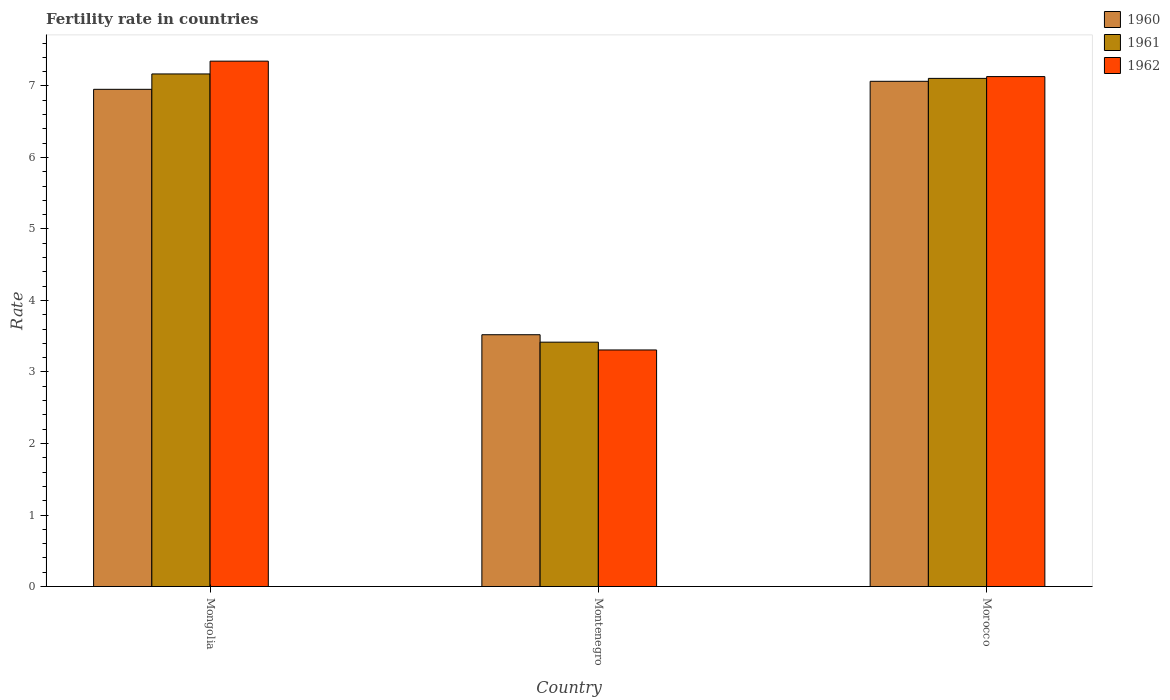How many different coloured bars are there?
Your response must be concise. 3. How many groups of bars are there?
Make the answer very short. 3. Are the number of bars per tick equal to the number of legend labels?
Give a very brief answer. Yes. How many bars are there on the 1st tick from the left?
Provide a short and direct response. 3. How many bars are there on the 2nd tick from the right?
Provide a succinct answer. 3. What is the label of the 1st group of bars from the left?
Give a very brief answer. Mongolia. In how many cases, is the number of bars for a given country not equal to the number of legend labels?
Provide a succinct answer. 0. What is the fertility rate in 1962 in Montenegro?
Offer a very short reply. 3.31. Across all countries, what is the maximum fertility rate in 1960?
Provide a succinct answer. 7.07. Across all countries, what is the minimum fertility rate in 1962?
Your answer should be very brief. 3.31. In which country was the fertility rate in 1960 maximum?
Give a very brief answer. Morocco. In which country was the fertility rate in 1962 minimum?
Your response must be concise. Montenegro. What is the total fertility rate in 1962 in the graph?
Keep it short and to the point. 17.79. What is the difference between the fertility rate in 1962 in Mongolia and that in Montenegro?
Your answer should be very brief. 4.04. What is the difference between the fertility rate in 1962 in Morocco and the fertility rate in 1960 in Mongolia?
Give a very brief answer. 0.18. What is the average fertility rate in 1961 per country?
Your answer should be compact. 5.9. What is the difference between the fertility rate of/in 1960 and fertility rate of/in 1962 in Montenegro?
Provide a short and direct response. 0.21. In how many countries, is the fertility rate in 1962 greater than 1?
Provide a short and direct response. 3. What is the ratio of the fertility rate in 1961 in Mongolia to that in Montenegro?
Your answer should be compact. 2.1. Is the fertility rate in 1960 in Mongolia less than that in Montenegro?
Give a very brief answer. No. What is the difference between the highest and the second highest fertility rate in 1960?
Offer a very short reply. -3.43. What is the difference between the highest and the lowest fertility rate in 1960?
Offer a very short reply. 3.54. In how many countries, is the fertility rate in 1962 greater than the average fertility rate in 1962 taken over all countries?
Offer a terse response. 2. Is the sum of the fertility rate in 1961 in Montenegro and Morocco greater than the maximum fertility rate in 1962 across all countries?
Offer a very short reply. Yes. How many bars are there?
Offer a terse response. 9. Are the values on the major ticks of Y-axis written in scientific E-notation?
Keep it short and to the point. No. Where does the legend appear in the graph?
Your answer should be compact. Top right. How are the legend labels stacked?
Your answer should be compact. Vertical. What is the title of the graph?
Give a very brief answer. Fertility rate in countries. What is the label or title of the Y-axis?
Your answer should be compact. Rate. What is the Rate of 1960 in Mongolia?
Ensure brevity in your answer.  6.95. What is the Rate of 1961 in Mongolia?
Provide a succinct answer. 7.17. What is the Rate of 1962 in Mongolia?
Keep it short and to the point. 7.35. What is the Rate of 1960 in Montenegro?
Offer a terse response. 3.52. What is the Rate in 1961 in Montenegro?
Your answer should be compact. 3.42. What is the Rate in 1962 in Montenegro?
Ensure brevity in your answer.  3.31. What is the Rate in 1960 in Morocco?
Your answer should be compact. 7.07. What is the Rate in 1961 in Morocco?
Your answer should be very brief. 7.11. What is the Rate in 1962 in Morocco?
Provide a short and direct response. 7.13. Across all countries, what is the maximum Rate in 1960?
Your answer should be very brief. 7.07. Across all countries, what is the maximum Rate of 1961?
Give a very brief answer. 7.17. Across all countries, what is the maximum Rate of 1962?
Offer a terse response. 7.35. Across all countries, what is the minimum Rate in 1960?
Ensure brevity in your answer.  3.52. Across all countries, what is the minimum Rate of 1961?
Give a very brief answer. 3.42. Across all countries, what is the minimum Rate in 1962?
Offer a terse response. 3.31. What is the total Rate of 1960 in the graph?
Your answer should be compact. 17.54. What is the total Rate of 1961 in the graph?
Your answer should be compact. 17.69. What is the total Rate of 1962 in the graph?
Ensure brevity in your answer.  17.79. What is the difference between the Rate of 1960 in Mongolia and that in Montenegro?
Provide a short and direct response. 3.43. What is the difference between the Rate of 1961 in Mongolia and that in Montenegro?
Provide a succinct answer. 3.75. What is the difference between the Rate in 1962 in Mongolia and that in Montenegro?
Ensure brevity in your answer.  4.04. What is the difference between the Rate in 1960 in Mongolia and that in Morocco?
Give a very brief answer. -0.11. What is the difference between the Rate of 1961 in Mongolia and that in Morocco?
Make the answer very short. 0.06. What is the difference between the Rate in 1962 in Mongolia and that in Morocco?
Make the answer very short. 0.22. What is the difference between the Rate in 1960 in Montenegro and that in Morocco?
Provide a short and direct response. -3.54. What is the difference between the Rate in 1961 in Montenegro and that in Morocco?
Your response must be concise. -3.69. What is the difference between the Rate of 1962 in Montenegro and that in Morocco?
Provide a short and direct response. -3.82. What is the difference between the Rate in 1960 in Mongolia and the Rate in 1961 in Montenegro?
Offer a terse response. 3.54. What is the difference between the Rate in 1960 in Mongolia and the Rate in 1962 in Montenegro?
Your answer should be very brief. 3.65. What is the difference between the Rate in 1961 in Mongolia and the Rate in 1962 in Montenegro?
Your response must be concise. 3.86. What is the difference between the Rate of 1960 in Mongolia and the Rate of 1961 in Morocco?
Provide a short and direct response. -0.15. What is the difference between the Rate of 1960 in Mongolia and the Rate of 1962 in Morocco?
Provide a succinct answer. -0.18. What is the difference between the Rate of 1961 in Mongolia and the Rate of 1962 in Morocco?
Your answer should be compact. 0.04. What is the difference between the Rate in 1960 in Montenegro and the Rate in 1961 in Morocco?
Your answer should be compact. -3.58. What is the difference between the Rate of 1960 in Montenegro and the Rate of 1962 in Morocco?
Your response must be concise. -3.61. What is the difference between the Rate in 1961 in Montenegro and the Rate in 1962 in Morocco?
Provide a short and direct response. -3.71. What is the average Rate of 1960 per country?
Your answer should be very brief. 5.85. What is the average Rate of 1961 per country?
Provide a short and direct response. 5.9. What is the average Rate in 1962 per country?
Make the answer very short. 5.93. What is the difference between the Rate of 1960 and Rate of 1961 in Mongolia?
Your answer should be very brief. -0.21. What is the difference between the Rate in 1960 and Rate in 1962 in Mongolia?
Provide a succinct answer. -0.39. What is the difference between the Rate of 1961 and Rate of 1962 in Mongolia?
Provide a succinct answer. -0.18. What is the difference between the Rate of 1960 and Rate of 1961 in Montenegro?
Offer a terse response. 0.1. What is the difference between the Rate in 1960 and Rate in 1962 in Montenegro?
Offer a very short reply. 0.21. What is the difference between the Rate of 1961 and Rate of 1962 in Montenegro?
Give a very brief answer. 0.11. What is the difference between the Rate in 1960 and Rate in 1961 in Morocco?
Provide a succinct answer. -0.04. What is the difference between the Rate in 1960 and Rate in 1962 in Morocco?
Ensure brevity in your answer.  -0.07. What is the difference between the Rate in 1961 and Rate in 1962 in Morocco?
Your answer should be compact. -0.03. What is the ratio of the Rate in 1960 in Mongolia to that in Montenegro?
Give a very brief answer. 1.97. What is the ratio of the Rate in 1961 in Mongolia to that in Montenegro?
Keep it short and to the point. 2.1. What is the ratio of the Rate of 1962 in Mongolia to that in Montenegro?
Give a very brief answer. 2.22. What is the ratio of the Rate in 1960 in Mongolia to that in Morocco?
Ensure brevity in your answer.  0.98. What is the ratio of the Rate in 1961 in Mongolia to that in Morocco?
Keep it short and to the point. 1.01. What is the ratio of the Rate of 1962 in Mongolia to that in Morocco?
Give a very brief answer. 1.03. What is the ratio of the Rate of 1960 in Montenegro to that in Morocco?
Offer a very short reply. 0.5. What is the ratio of the Rate of 1961 in Montenegro to that in Morocco?
Offer a very short reply. 0.48. What is the ratio of the Rate in 1962 in Montenegro to that in Morocco?
Provide a succinct answer. 0.46. What is the difference between the highest and the second highest Rate of 1960?
Ensure brevity in your answer.  0.11. What is the difference between the highest and the second highest Rate in 1961?
Offer a very short reply. 0.06. What is the difference between the highest and the second highest Rate of 1962?
Keep it short and to the point. 0.22. What is the difference between the highest and the lowest Rate in 1960?
Ensure brevity in your answer.  3.54. What is the difference between the highest and the lowest Rate in 1961?
Your answer should be very brief. 3.75. What is the difference between the highest and the lowest Rate in 1962?
Provide a short and direct response. 4.04. 